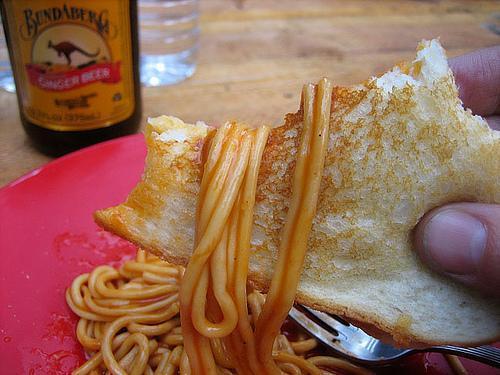How many cups are in the picture?
Give a very brief answer. 1. How many bottles are in the photo?
Give a very brief answer. 2. How many apple brand laptops can you see?
Give a very brief answer. 0. 